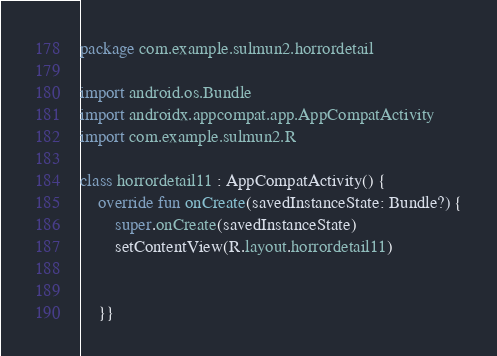Convert code to text. <code><loc_0><loc_0><loc_500><loc_500><_Kotlin_>package com.example.sulmun2.horrordetail

import android.os.Bundle
import androidx.appcompat.app.AppCompatActivity
import com.example.sulmun2.R

class horrordetail11 : AppCompatActivity() {
    override fun onCreate(savedInstanceState: Bundle?) {
        super.onCreate(savedInstanceState)
        setContentView(R.layout.horrordetail11)


    }}
</code> 